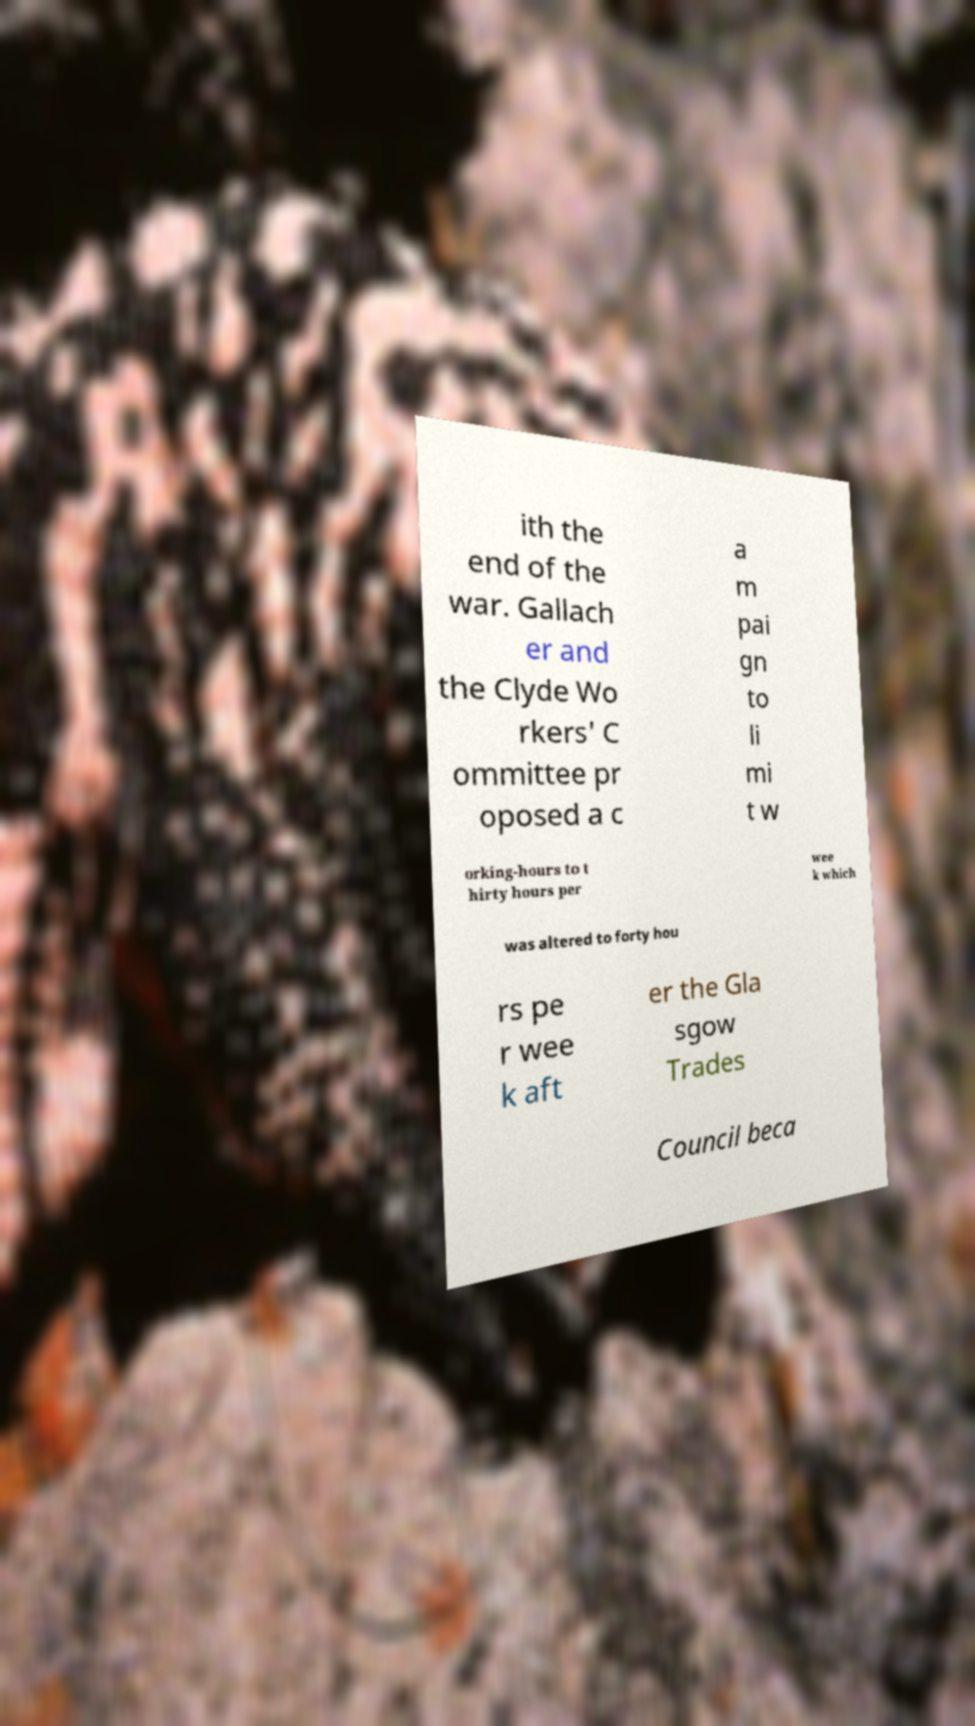There's text embedded in this image that I need extracted. Can you transcribe it verbatim? ith the end of the war. Gallach er and the Clyde Wo rkers' C ommittee pr oposed a c a m pai gn to li mi t w orking-hours to t hirty hours per wee k which was altered to forty hou rs pe r wee k aft er the Gla sgow Trades Council beca 